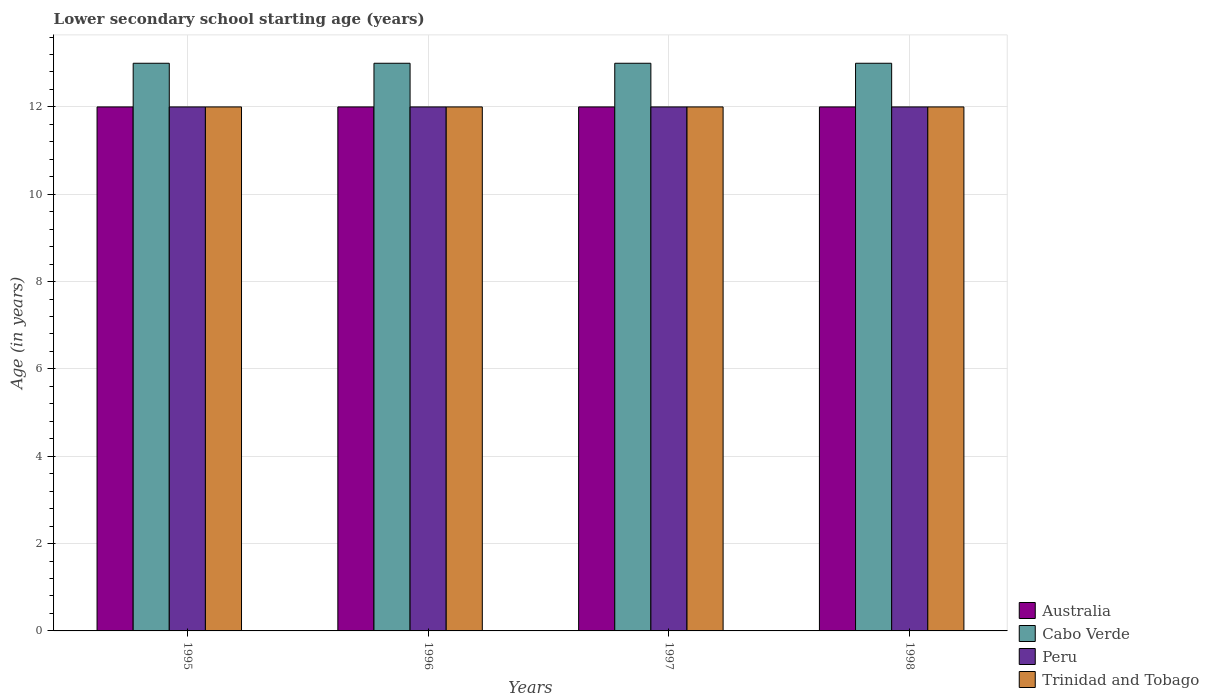How many groups of bars are there?
Keep it short and to the point. 4. Are the number of bars per tick equal to the number of legend labels?
Ensure brevity in your answer.  Yes. Are the number of bars on each tick of the X-axis equal?
Keep it short and to the point. Yes. How many bars are there on the 1st tick from the left?
Your response must be concise. 4. How many bars are there on the 1st tick from the right?
Give a very brief answer. 4. In how many cases, is the number of bars for a given year not equal to the number of legend labels?
Make the answer very short. 0. What is the lower secondary school starting age of children in Cabo Verde in 1996?
Your response must be concise. 13. Across all years, what is the maximum lower secondary school starting age of children in Australia?
Provide a succinct answer. 12. Across all years, what is the minimum lower secondary school starting age of children in Peru?
Keep it short and to the point. 12. In which year was the lower secondary school starting age of children in Trinidad and Tobago maximum?
Offer a terse response. 1995. In which year was the lower secondary school starting age of children in Trinidad and Tobago minimum?
Ensure brevity in your answer.  1995. What is the total lower secondary school starting age of children in Peru in the graph?
Offer a terse response. 48. What is the difference between the lower secondary school starting age of children in Australia in 1998 and the lower secondary school starting age of children in Cabo Verde in 1995?
Your response must be concise. -1. What is the average lower secondary school starting age of children in Cabo Verde per year?
Offer a terse response. 13. In the year 1995, what is the difference between the lower secondary school starting age of children in Cabo Verde and lower secondary school starting age of children in Peru?
Ensure brevity in your answer.  1. What is the ratio of the lower secondary school starting age of children in Trinidad and Tobago in 1995 to that in 1998?
Provide a succinct answer. 1. What is the difference between the highest and the second highest lower secondary school starting age of children in Cabo Verde?
Offer a very short reply. 0. What is the difference between the highest and the lowest lower secondary school starting age of children in Cabo Verde?
Ensure brevity in your answer.  0. In how many years, is the lower secondary school starting age of children in Trinidad and Tobago greater than the average lower secondary school starting age of children in Trinidad and Tobago taken over all years?
Provide a short and direct response. 0. Is it the case that in every year, the sum of the lower secondary school starting age of children in Peru and lower secondary school starting age of children in Australia is greater than the sum of lower secondary school starting age of children in Trinidad and Tobago and lower secondary school starting age of children in Cabo Verde?
Your response must be concise. No. What does the 3rd bar from the left in 1998 represents?
Your answer should be compact. Peru. What does the 4th bar from the right in 1997 represents?
Ensure brevity in your answer.  Australia. Is it the case that in every year, the sum of the lower secondary school starting age of children in Australia and lower secondary school starting age of children in Peru is greater than the lower secondary school starting age of children in Trinidad and Tobago?
Your response must be concise. Yes. How many bars are there?
Offer a terse response. 16. How many years are there in the graph?
Provide a short and direct response. 4. Does the graph contain grids?
Keep it short and to the point. Yes. How many legend labels are there?
Your answer should be compact. 4. What is the title of the graph?
Offer a terse response. Lower secondary school starting age (years). What is the label or title of the Y-axis?
Offer a terse response. Age (in years). What is the Age (in years) of Australia in 1995?
Give a very brief answer. 12. What is the Age (in years) of Cabo Verde in 1995?
Your answer should be very brief. 13. What is the Age (in years) of Peru in 1995?
Your response must be concise. 12. What is the Age (in years) of Trinidad and Tobago in 1995?
Keep it short and to the point. 12. What is the Age (in years) in Australia in 1996?
Provide a short and direct response. 12. What is the Age (in years) of Peru in 1996?
Your answer should be very brief. 12. What is the Age (in years) in Australia in 1997?
Offer a very short reply. 12. What is the Age (in years) in Peru in 1997?
Provide a succinct answer. 12. What is the Age (in years) of Trinidad and Tobago in 1997?
Offer a very short reply. 12. What is the Age (in years) in Australia in 1998?
Ensure brevity in your answer.  12. What is the Age (in years) in Peru in 1998?
Give a very brief answer. 12. What is the Age (in years) in Trinidad and Tobago in 1998?
Your answer should be compact. 12. Across all years, what is the maximum Age (in years) in Australia?
Give a very brief answer. 12. Across all years, what is the maximum Age (in years) of Cabo Verde?
Ensure brevity in your answer.  13. Across all years, what is the minimum Age (in years) in Cabo Verde?
Ensure brevity in your answer.  13. Across all years, what is the minimum Age (in years) of Trinidad and Tobago?
Offer a very short reply. 12. What is the total Age (in years) in Australia in the graph?
Your answer should be very brief. 48. What is the difference between the Age (in years) in Cabo Verde in 1995 and that in 1996?
Make the answer very short. 0. What is the difference between the Age (in years) in Peru in 1995 and that in 1996?
Provide a succinct answer. 0. What is the difference between the Age (in years) of Trinidad and Tobago in 1995 and that in 1996?
Your answer should be very brief. 0. What is the difference between the Age (in years) of Cabo Verde in 1995 and that in 1997?
Your answer should be very brief. 0. What is the difference between the Age (in years) of Peru in 1995 and that in 1997?
Your response must be concise. 0. What is the difference between the Age (in years) in Trinidad and Tobago in 1995 and that in 1997?
Provide a short and direct response. 0. What is the difference between the Age (in years) in Australia in 1995 and that in 1998?
Make the answer very short. 0. What is the difference between the Age (in years) in Cabo Verde in 1995 and that in 1998?
Make the answer very short. 0. What is the difference between the Age (in years) in Peru in 1995 and that in 1998?
Provide a short and direct response. 0. What is the difference between the Age (in years) of Trinidad and Tobago in 1995 and that in 1998?
Your response must be concise. 0. What is the difference between the Age (in years) of Australia in 1996 and that in 1997?
Provide a succinct answer. 0. What is the difference between the Age (in years) of Cabo Verde in 1996 and that in 1997?
Your answer should be very brief. 0. What is the difference between the Age (in years) in Trinidad and Tobago in 1996 and that in 1998?
Give a very brief answer. 0. What is the difference between the Age (in years) of Australia in 1997 and that in 1998?
Offer a terse response. 0. What is the difference between the Age (in years) in Trinidad and Tobago in 1997 and that in 1998?
Ensure brevity in your answer.  0. What is the difference between the Age (in years) of Cabo Verde in 1995 and the Age (in years) of Peru in 1996?
Make the answer very short. 1. What is the difference between the Age (in years) in Peru in 1995 and the Age (in years) in Trinidad and Tobago in 1996?
Offer a very short reply. 0. What is the difference between the Age (in years) in Australia in 1995 and the Age (in years) in Cabo Verde in 1997?
Offer a very short reply. -1. What is the difference between the Age (in years) in Australia in 1995 and the Age (in years) in Peru in 1998?
Offer a very short reply. 0. What is the difference between the Age (in years) of Australia in 1995 and the Age (in years) of Trinidad and Tobago in 1998?
Make the answer very short. 0. What is the difference between the Age (in years) of Cabo Verde in 1995 and the Age (in years) of Peru in 1998?
Keep it short and to the point. 1. What is the difference between the Age (in years) of Australia in 1996 and the Age (in years) of Peru in 1997?
Provide a succinct answer. 0. What is the difference between the Age (in years) in Cabo Verde in 1996 and the Age (in years) in Peru in 1998?
Ensure brevity in your answer.  1. What is the difference between the Age (in years) in Cabo Verde in 1996 and the Age (in years) in Trinidad and Tobago in 1998?
Ensure brevity in your answer.  1. What is the difference between the Age (in years) in Australia in 1997 and the Age (in years) in Cabo Verde in 1998?
Your answer should be compact. -1. What is the difference between the Age (in years) in Australia in 1997 and the Age (in years) in Peru in 1998?
Give a very brief answer. 0. What is the difference between the Age (in years) in Cabo Verde in 1997 and the Age (in years) in Peru in 1998?
Offer a terse response. 1. What is the difference between the Age (in years) in Peru in 1997 and the Age (in years) in Trinidad and Tobago in 1998?
Your answer should be compact. 0. What is the average Age (in years) in Australia per year?
Make the answer very short. 12. What is the average Age (in years) of Peru per year?
Give a very brief answer. 12. In the year 1995, what is the difference between the Age (in years) in Australia and Age (in years) in Cabo Verde?
Offer a very short reply. -1. In the year 1995, what is the difference between the Age (in years) of Australia and Age (in years) of Peru?
Offer a terse response. 0. In the year 1995, what is the difference between the Age (in years) of Cabo Verde and Age (in years) of Peru?
Your answer should be very brief. 1. In the year 1995, what is the difference between the Age (in years) of Peru and Age (in years) of Trinidad and Tobago?
Offer a very short reply. 0. In the year 1996, what is the difference between the Age (in years) in Australia and Age (in years) in Trinidad and Tobago?
Your response must be concise. 0. In the year 1997, what is the difference between the Age (in years) of Australia and Age (in years) of Cabo Verde?
Offer a very short reply. -1. In the year 1997, what is the difference between the Age (in years) in Australia and Age (in years) in Peru?
Make the answer very short. 0. In the year 1997, what is the difference between the Age (in years) in Cabo Verde and Age (in years) in Peru?
Make the answer very short. 1. In the year 1997, what is the difference between the Age (in years) in Peru and Age (in years) in Trinidad and Tobago?
Your response must be concise. 0. In the year 1998, what is the difference between the Age (in years) of Australia and Age (in years) of Cabo Verde?
Your answer should be compact. -1. In the year 1998, what is the difference between the Age (in years) of Cabo Verde and Age (in years) of Peru?
Offer a very short reply. 1. In the year 1998, what is the difference between the Age (in years) of Cabo Verde and Age (in years) of Trinidad and Tobago?
Your answer should be compact. 1. What is the ratio of the Age (in years) of Australia in 1995 to that in 1996?
Ensure brevity in your answer.  1. What is the ratio of the Age (in years) in Cabo Verde in 1995 to that in 1996?
Keep it short and to the point. 1. What is the ratio of the Age (in years) of Peru in 1995 to that in 1996?
Offer a terse response. 1. What is the ratio of the Age (in years) in Trinidad and Tobago in 1995 to that in 1996?
Offer a very short reply. 1. What is the ratio of the Age (in years) in Australia in 1995 to that in 1997?
Offer a very short reply. 1. What is the ratio of the Age (in years) in Peru in 1995 to that in 1997?
Offer a very short reply. 1. What is the ratio of the Age (in years) in Cabo Verde in 1996 to that in 1997?
Offer a terse response. 1. What is the ratio of the Age (in years) of Trinidad and Tobago in 1996 to that in 1997?
Your answer should be compact. 1. What is the ratio of the Age (in years) of Australia in 1996 to that in 1998?
Provide a succinct answer. 1. What is the ratio of the Age (in years) of Peru in 1996 to that in 1998?
Provide a succinct answer. 1. What is the ratio of the Age (in years) of Peru in 1997 to that in 1998?
Ensure brevity in your answer.  1. What is the ratio of the Age (in years) of Trinidad and Tobago in 1997 to that in 1998?
Keep it short and to the point. 1. What is the difference between the highest and the second highest Age (in years) of Cabo Verde?
Provide a succinct answer. 0. What is the difference between the highest and the second highest Age (in years) of Peru?
Provide a succinct answer. 0. What is the difference between the highest and the lowest Age (in years) of Cabo Verde?
Your response must be concise. 0. What is the difference between the highest and the lowest Age (in years) of Trinidad and Tobago?
Give a very brief answer. 0. 